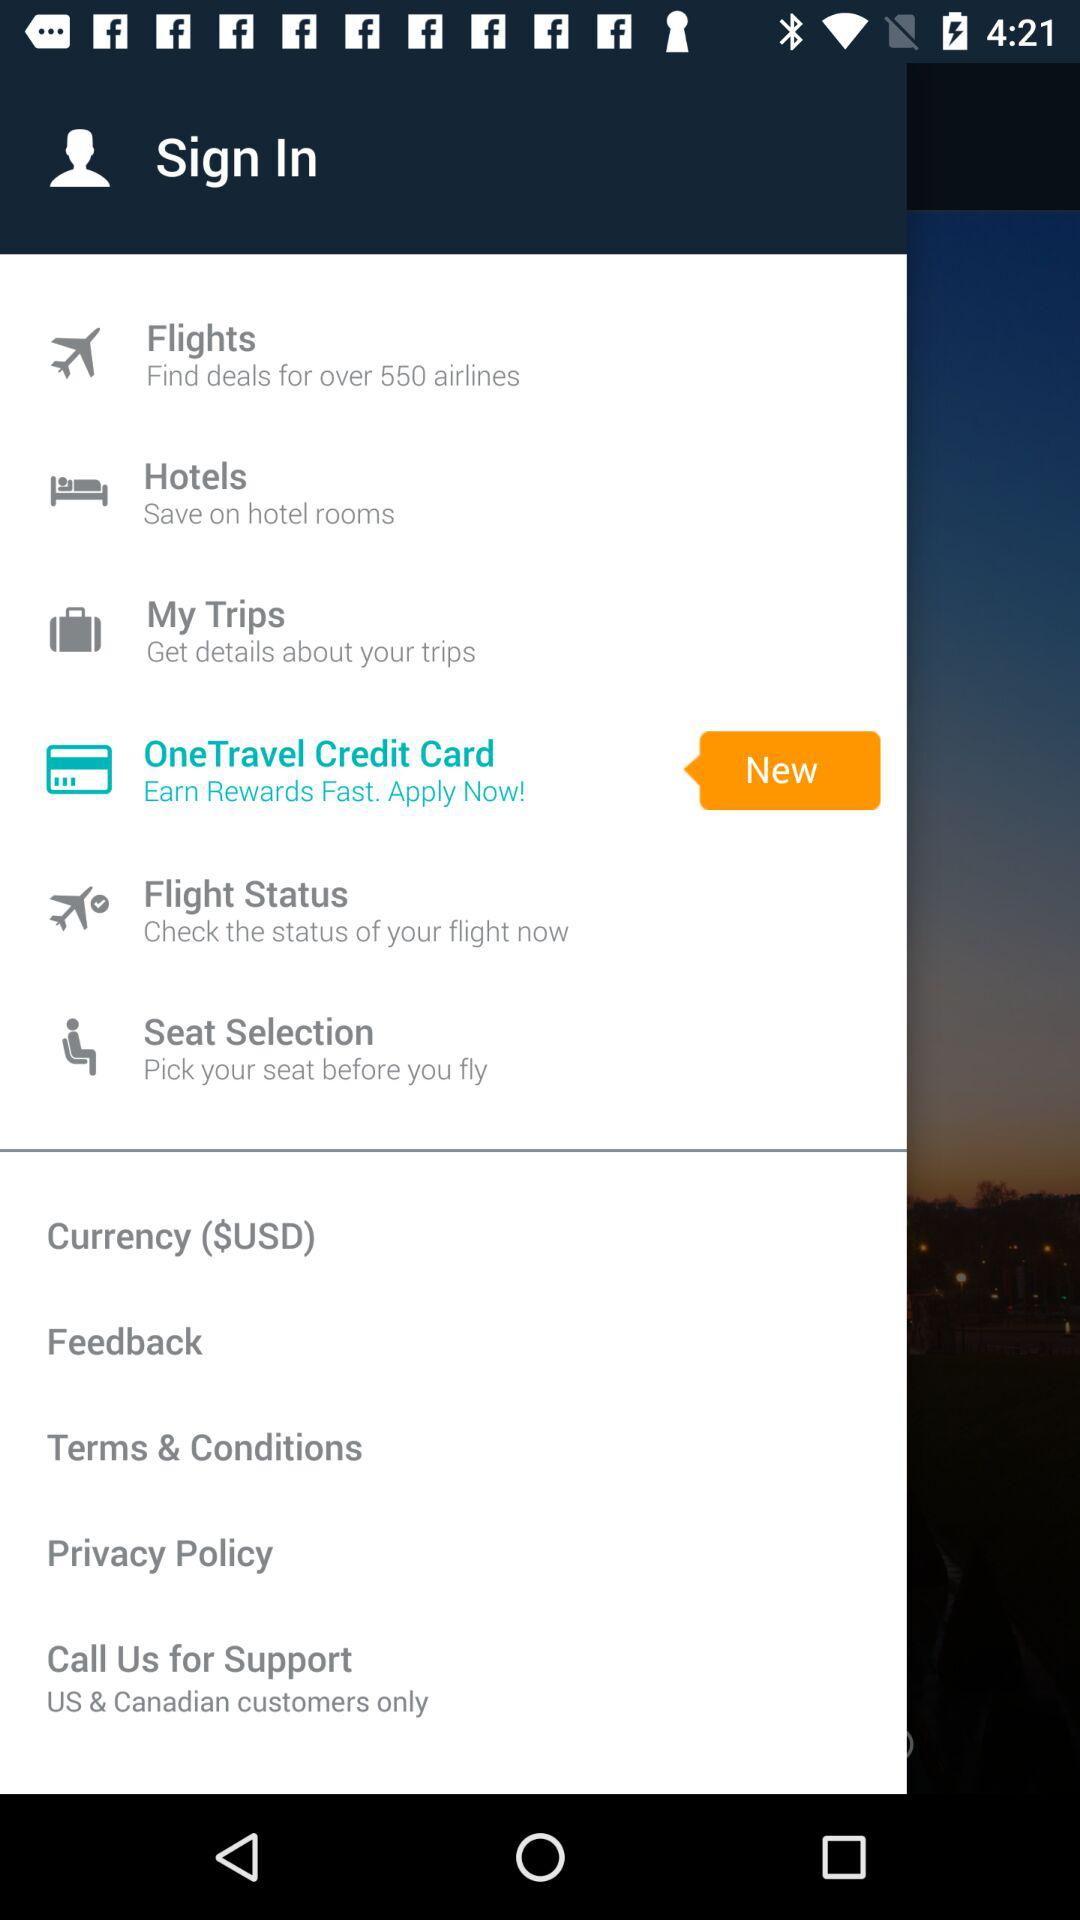What types of customers does call support serve? The types of customers that call support serves are "US & Canadian customers only". 